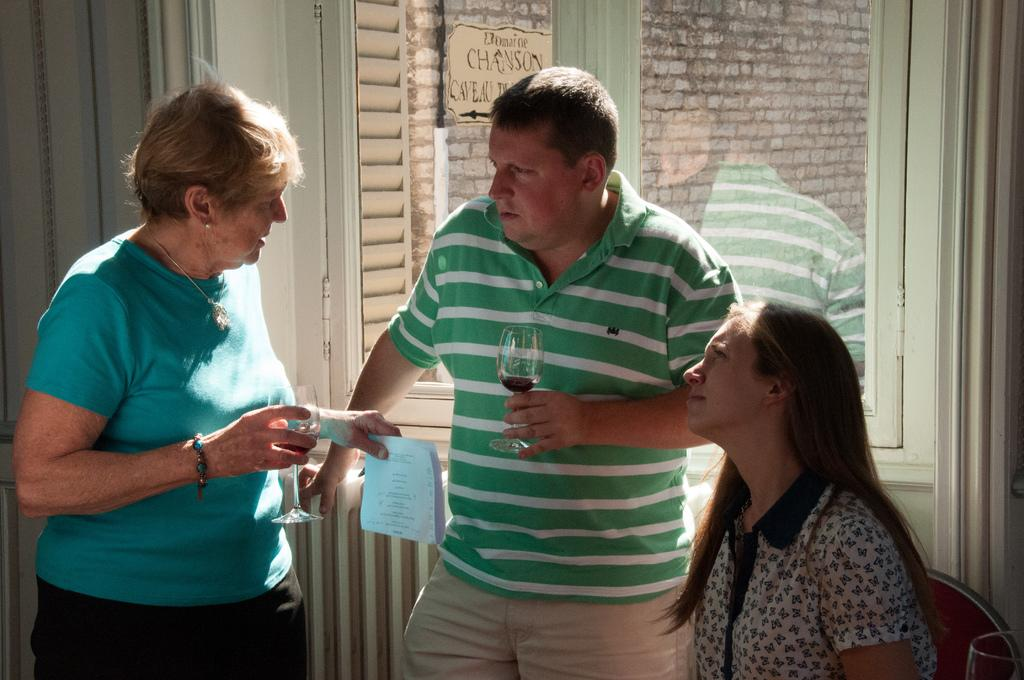How many people are on the floor in the image? There are three persons on the floor in the image. What objects can be seen in the image besides the people? There are glasses and a chair visible in the image. What type of window is present in the image? There is a glass window in the image. What type of architectural feature is present in the image? There is a wall in the image. Can you describe the setting where the image might have been taken? The image may have been taken in a hall. What type of art is displayed on the chin of the person in the image? There is no art displayed on the chin of any person in the image. Who is the servant in the image? There is no servant present in the image. 